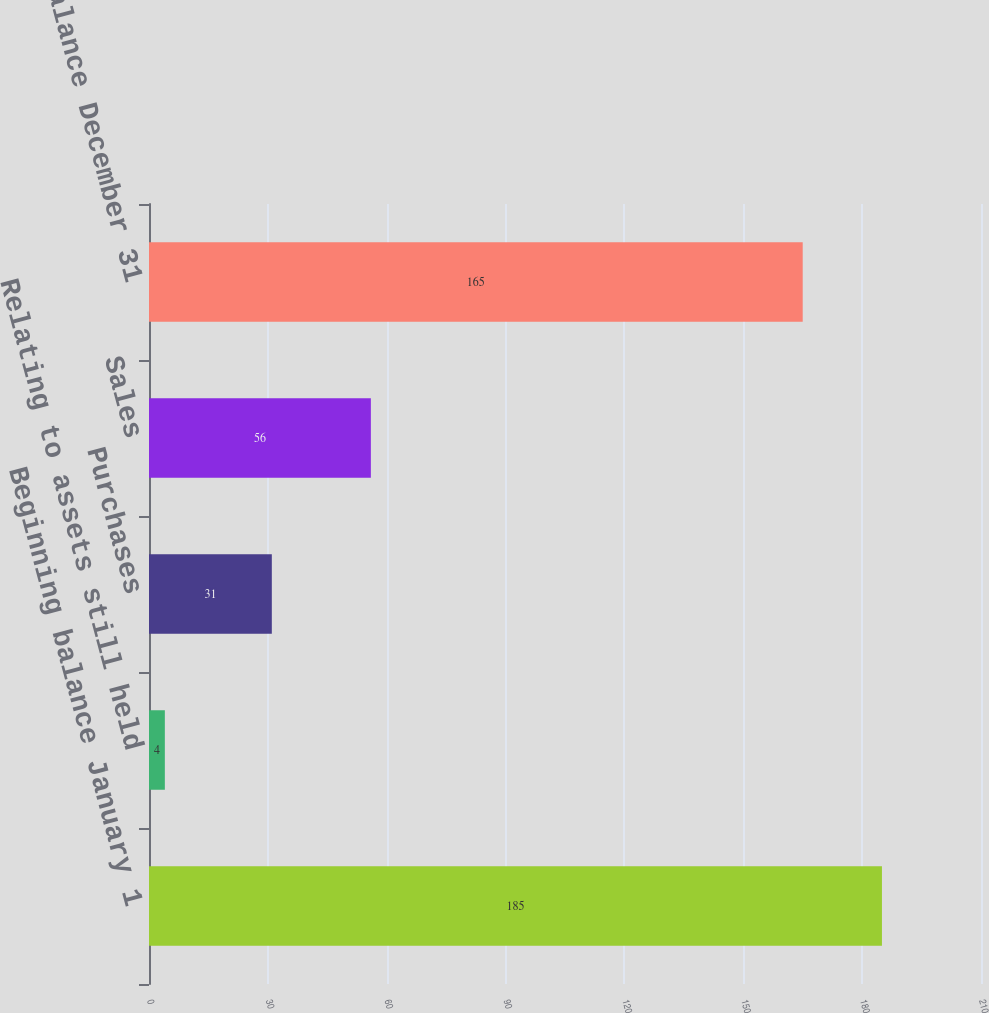<chart> <loc_0><loc_0><loc_500><loc_500><bar_chart><fcel>Beginning balance January 1<fcel>Relating to assets still held<fcel>Purchases<fcel>Sales<fcel>Ending balance December 31<nl><fcel>185<fcel>4<fcel>31<fcel>56<fcel>165<nl></chart> 